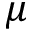<formula> <loc_0><loc_0><loc_500><loc_500>\mu</formula> 